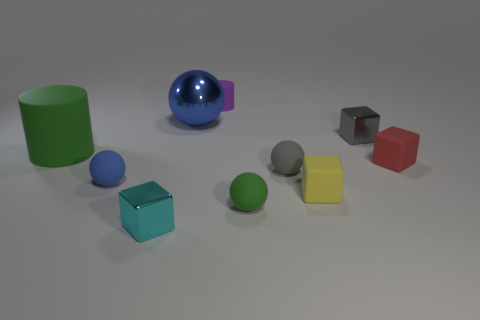Subtract 1 blocks. How many blocks are left? 3 Subtract all blocks. How many objects are left? 6 Subtract 0 brown balls. How many objects are left? 10 Subtract all big green rubber objects. Subtract all gray shiny things. How many objects are left? 8 Add 3 large blue metallic balls. How many large blue metallic balls are left? 4 Add 7 tiny red balls. How many tiny red balls exist? 7 